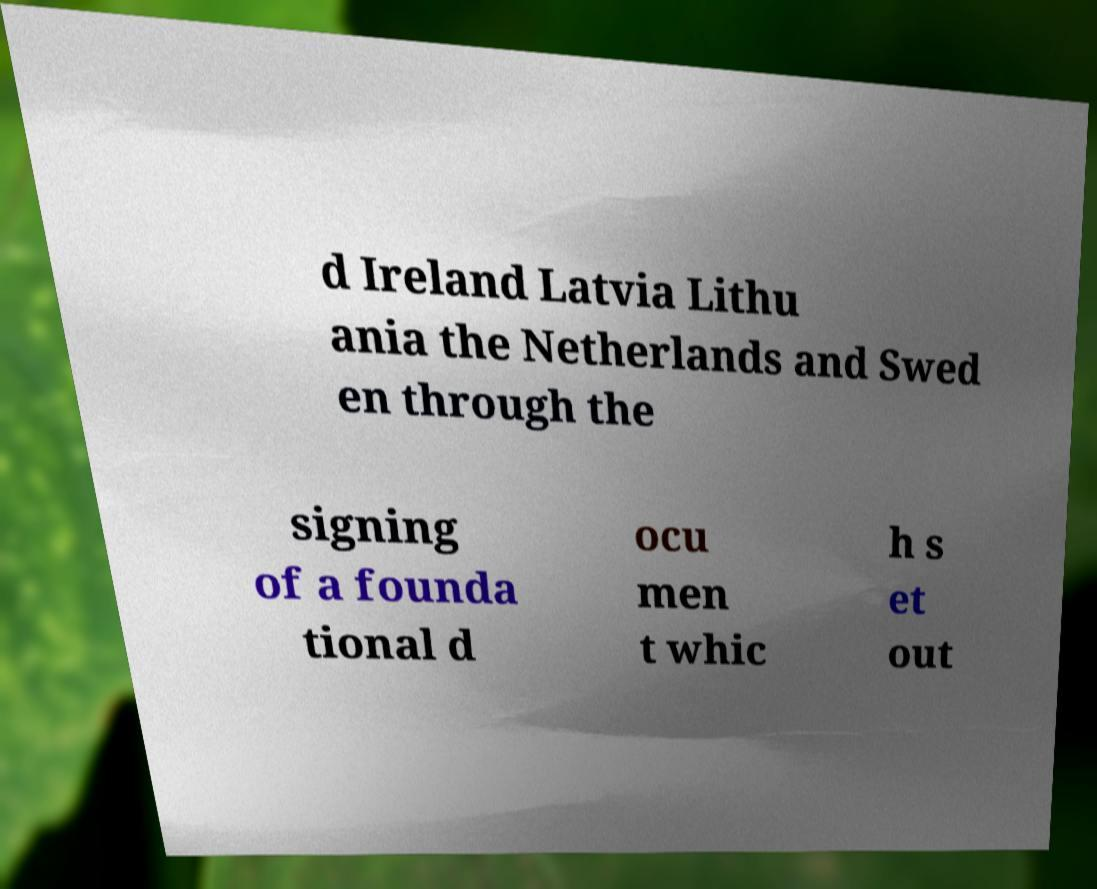Could you extract and type out the text from this image? d Ireland Latvia Lithu ania the Netherlands and Swed en through the signing of a founda tional d ocu men t whic h s et out 